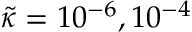Convert formula to latex. <formula><loc_0><loc_0><loc_500><loc_500>\widetilde { \kappa } = 1 0 ^ { - 6 } , 1 0 ^ { - 4 }</formula> 